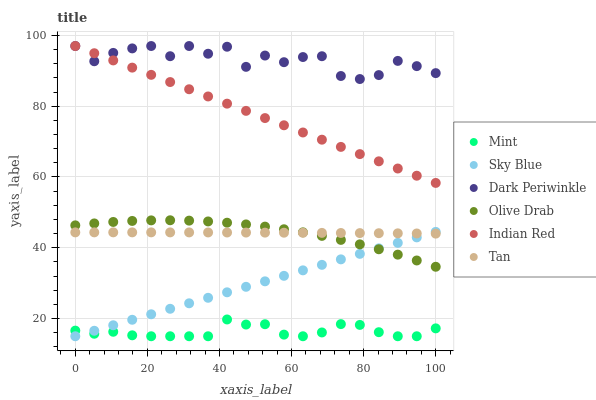Does Mint have the minimum area under the curve?
Answer yes or no. Yes. Does Dark Periwinkle have the maximum area under the curve?
Answer yes or no. Yes. Does Sky Blue have the minimum area under the curve?
Answer yes or no. No. Does Sky Blue have the maximum area under the curve?
Answer yes or no. No. Is Sky Blue the smoothest?
Answer yes or no. Yes. Is Dark Periwinkle the roughest?
Answer yes or no. Yes. Is Tan the smoothest?
Answer yes or no. No. Is Tan the roughest?
Answer yes or no. No. Does Sky Blue have the lowest value?
Answer yes or no. Yes. Does Tan have the lowest value?
Answer yes or no. No. Does Dark Periwinkle have the highest value?
Answer yes or no. Yes. Does Sky Blue have the highest value?
Answer yes or no. No. Is Olive Drab less than Dark Periwinkle?
Answer yes or no. Yes. Is Indian Red greater than Tan?
Answer yes or no. Yes. Does Dark Periwinkle intersect Indian Red?
Answer yes or no. Yes. Is Dark Periwinkle less than Indian Red?
Answer yes or no. No. Is Dark Periwinkle greater than Indian Red?
Answer yes or no. No. Does Olive Drab intersect Dark Periwinkle?
Answer yes or no. No. 